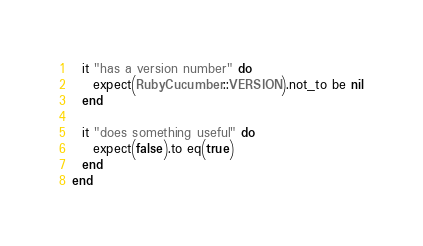<code> <loc_0><loc_0><loc_500><loc_500><_Ruby_>  it "has a version number" do
    expect(RubyCucumber::VERSION).not_to be nil
  end

  it "does something useful" do
    expect(false).to eq(true)
  end
end
</code> 